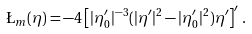Convert formula to latex. <formula><loc_0><loc_0><loc_500><loc_500>\L _ { m } ( \eta ) = - 4 \left [ | \eta _ { 0 } ^ { \prime } | ^ { - 3 } ( | \eta ^ { \prime } | ^ { 2 } - | \eta _ { 0 } ^ { \prime } | ^ { 2 } ) \eta ^ { \prime } \right ] ^ { \prime } \, .</formula> 